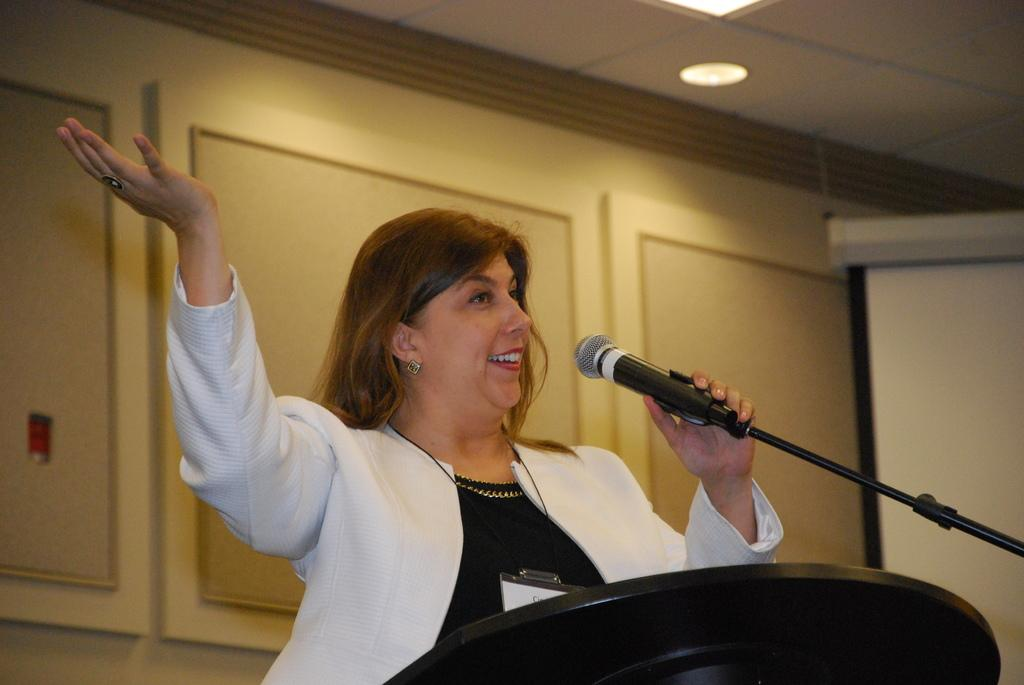Who is the main subject in the image? There is a woman in the image. What is the woman doing near the podium? The woman is standing near a podium. What is the woman holding in her hand? The woman is holding a microphone. What is the woman doing with the microphone? The woman is speaking. What can be seen in the background of the image? There is a wall in the background of the image. What building is the woman about to discover in the image? There is no building present in the image, and the woman is not shown discovering anything. 